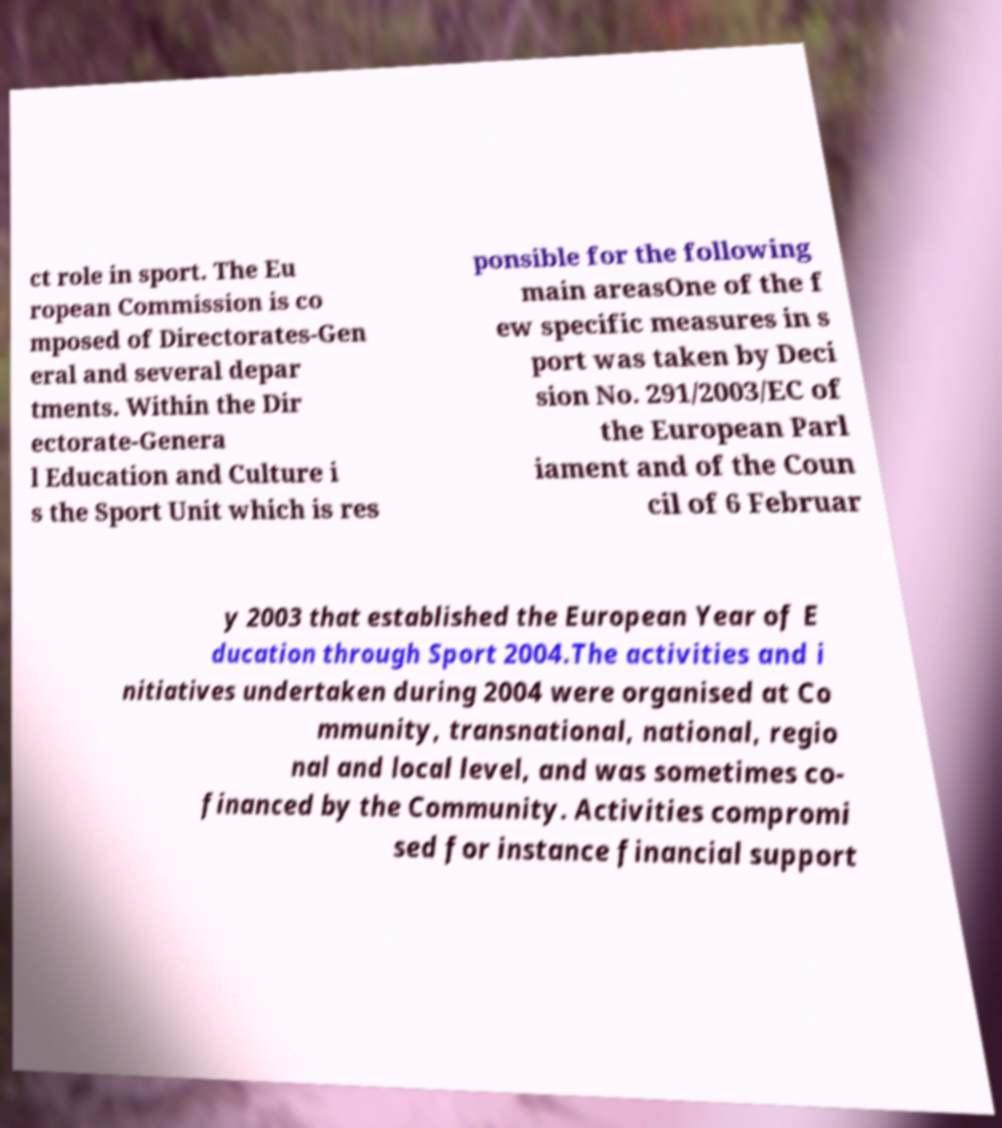I need the written content from this picture converted into text. Can you do that? ct role in sport. The Eu ropean Commission is co mposed of Directorates-Gen eral and several depar tments. Within the Dir ectorate-Genera l Education and Culture i s the Sport Unit which is res ponsible for the following main areasOne of the f ew specific measures in s port was taken by Deci sion No. 291/2003/EC of the European Parl iament and of the Coun cil of 6 Februar y 2003 that established the European Year of E ducation through Sport 2004.The activities and i nitiatives undertaken during 2004 were organised at Co mmunity, transnational, national, regio nal and local level, and was sometimes co- financed by the Community. Activities compromi sed for instance financial support 